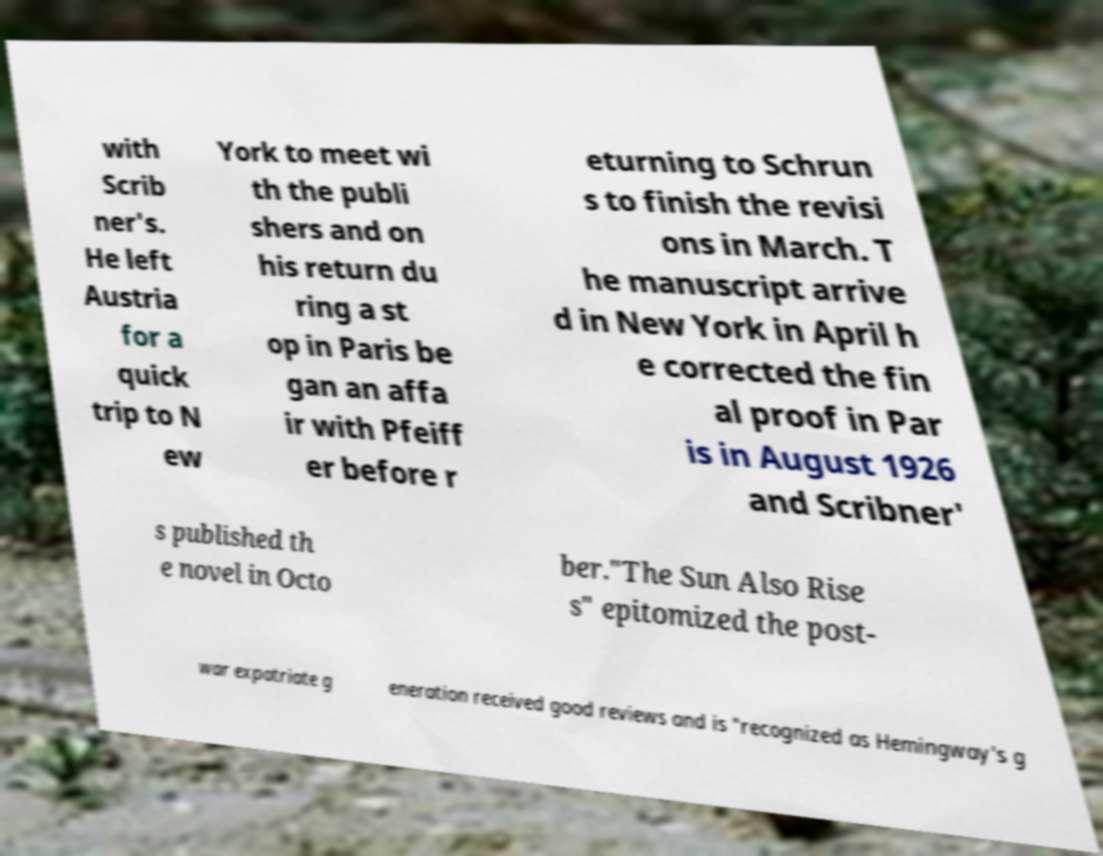What messages or text are displayed in this image? I need them in a readable, typed format. with Scrib ner's. He left Austria for a quick trip to N ew York to meet wi th the publi shers and on his return du ring a st op in Paris be gan an affa ir with Pfeiff er before r eturning to Schrun s to finish the revisi ons in March. T he manuscript arrive d in New York in April h e corrected the fin al proof in Par is in August 1926 and Scribner' s published th e novel in Octo ber."The Sun Also Rise s" epitomized the post- war expatriate g eneration received good reviews and is "recognized as Hemingway's g 